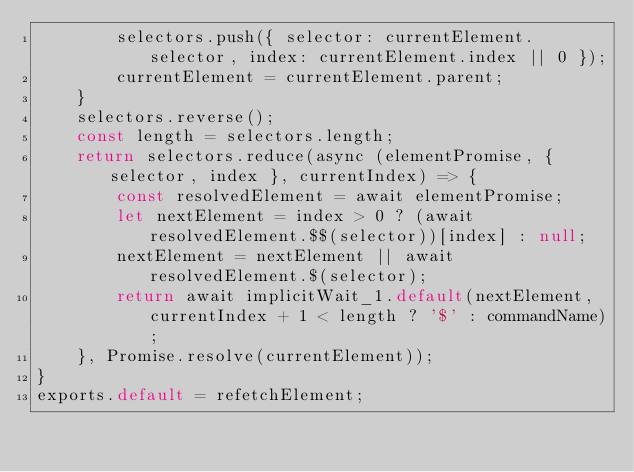<code> <loc_0><loc_0><loc_500><loc_500><_JavaScript_>        selectors.push({ selector: currentElement.selector, index: currentElement.index || 0 });
        currentElement = currentElement.parent;
    }
    selectors.reverse();
    const length = selectors.length;
    return selectors.reduce(async (elementPromise, { selector, index }, currentIndex) => {
        const resolvedElement = await elementPromise;
        let nextElement = index > 0 ? (await resolvedElement.$$(selector))[index] : null;
        nextElement = nextElement || await resolvedElement.$(selector);
        return await implicitWait_1.default(nextElement, currentIndex + 1 < length ? '$' : commandName);
    }, Promise.resolve(currentElement));
}
exports.default = refetchElement;
</code> 